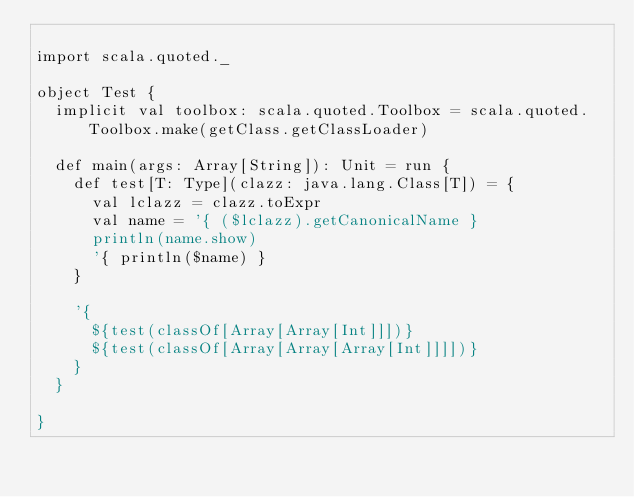<code> <loc_0><loc_0><loc_500><loc_500><_Scala_>
import scala.quoted._

object Test {
  implicit val toolbox: scala.quoted.Toolbox = scala.quoted.Toolbox.make(getClass.getClassLoader)

  def main(args: Array[String]): Unit = run {
    def test[T: Type](clazz: java.lang.Class[T]) = {
      val lclazz = clazz.toExpr
      val name = '{ ($lclazz).getCanonicalName }
      println(name.show)
      '{ println($name) }
    }

    '{
      ${test(classOf[Array[Array[Int]]])}
      ${test(classOf[Array[Array[Array[Int]]]])}
    }
  }

}
</code> 